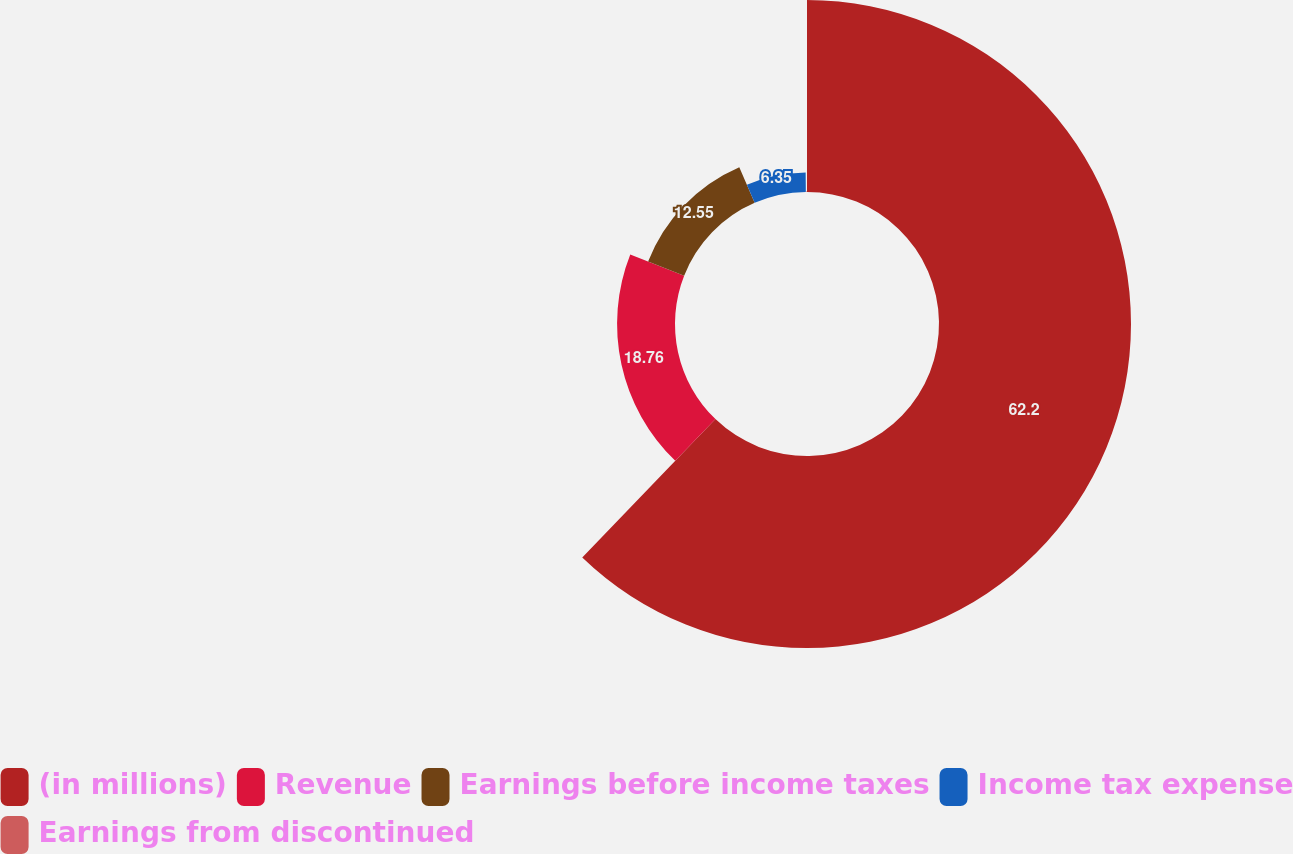Convert chart. <chart><loc_0><loc_0><loc_500><loc_500><pie_chart><fcel>(in millions)<fcel>Revenue<fcel>Earnings before income taxes<fcel>Income tax expense<fcel>Earnings from discontinued<nl><fcel>62.2%<fcel>18.76%<fcel>12.55%<fcel>6.35%<fcel>0.14%<nl></chart> 